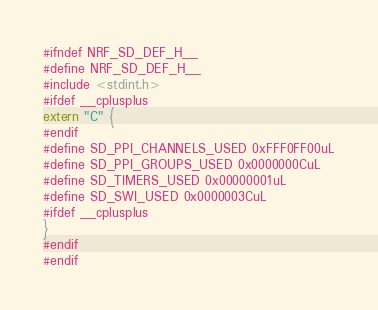<code> <loc_0><loc_0><loc_500><loc_500><_C_>#ifndef NRF_SD_DEF_H__
#define NRF_SD_DEF_H__ 
#include <stdint.h>
#ifdef __cplusplus
extern "C" {
#endif
#define SD_PPI_CHANNELS_USED 0xFFF0FF00uL
#define SD_PPI_GROUPS_USED 0x0000000CuL
#define SD_TIMERS_USED 0x00000001uL
#define SD_SWI_USED 0x0000003CuL
#ifdef __cplusplus
}
#endif
#endif
</code> 